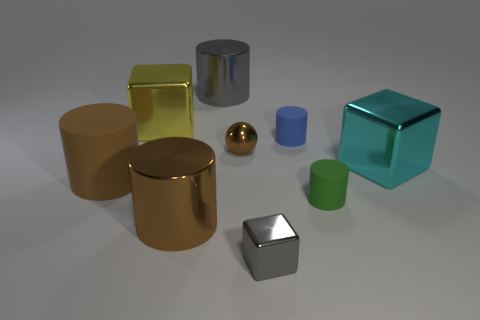Subtract all big shiny blocks. How many blocks are left? 1 Subtract 3 cylinders. How many cylinders are left? 2 Subtract all blue cylinders. How many cylinders are left? 4 Add 1 small green cylinders. How many objects exist? 10 Subtract all blue cylinders. Subtract all blue cubes. How many cylinders are left? 4 Subtract all balls. How many objects are left? 8 Add 5 big cyan shiny blocks. How many big cyan shiny blocks are left? 6 Add 8 tiny cyan balls. How many tiny cyan balls exist? 8 Subtract 0 red balls. How many objects are left? 9 Subtract all gray blocks. Subtract all big gray shiny things. How many objects are left? 7 